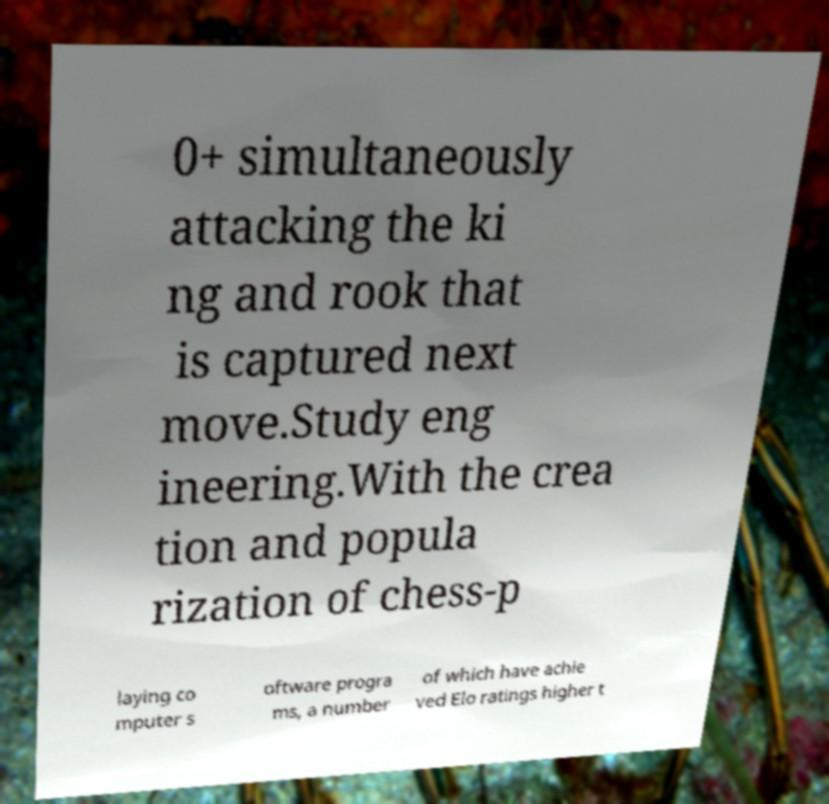Could you extract and type out the text from this image? 0+ simultaneously attacking the ki ng and rook that is captured next move.Study eng ineering.With the crea tion and popula rization of chess-p laying co mputer s oftware progra ms, a number of which have achie ved Elo ratings higher t 